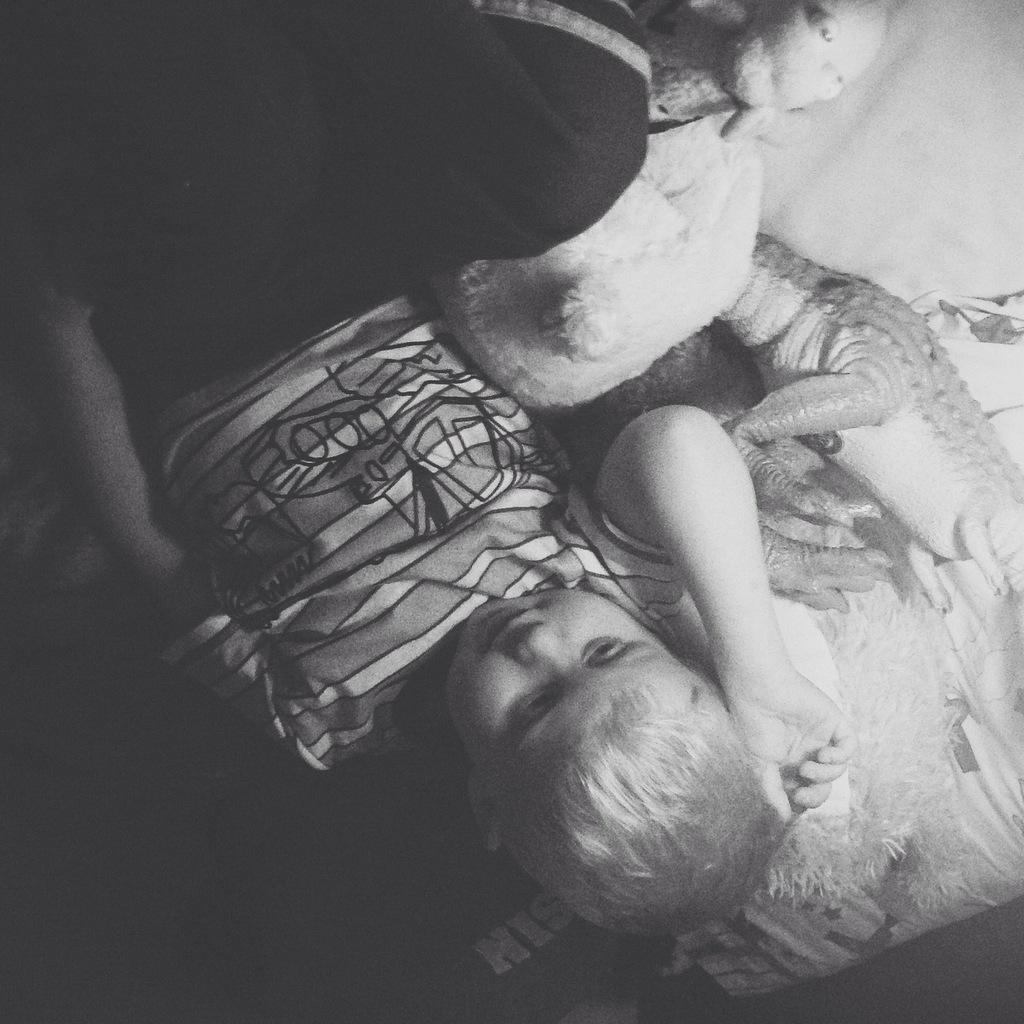What is the main subject of the image? There is a person sleeping in the image. What else can be seen on the bed? There are toys on the bed. How is the image presented in terms of color? The image is in black and white. What type of mitten is the person wearing in the image? There is no mitten visible in the image, as it is in black and white and the person is sleeping. 